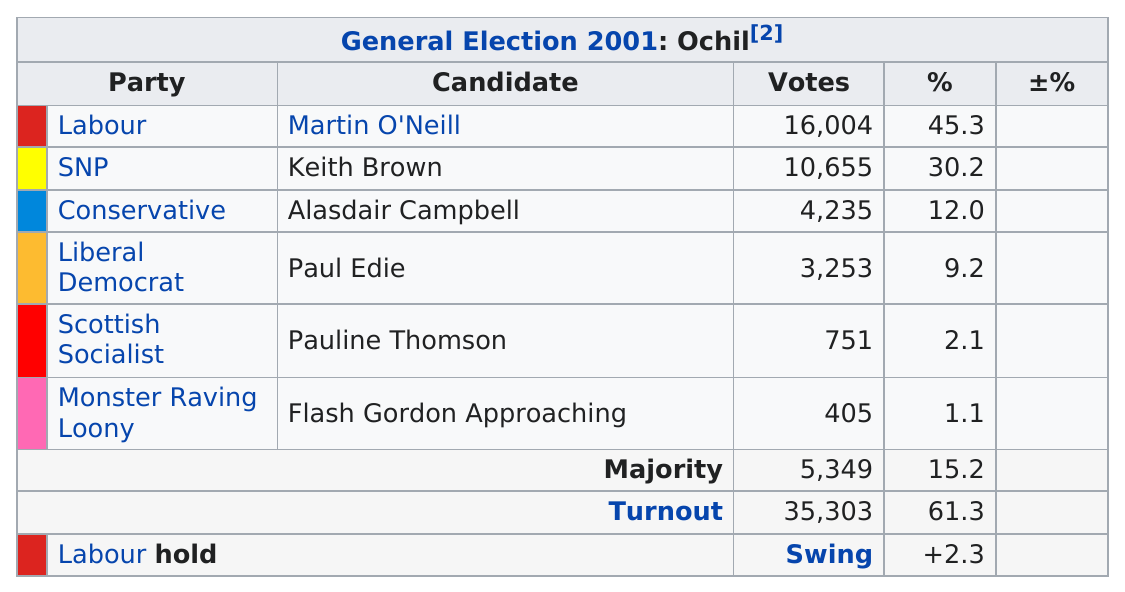Draw attention to some important aspects in this diagram. The SNP or the Conservative Party received a greater percentage of the vote in the 2001 General Election in Ochil. The following candidates received over one thousand votes: Martin O'Neill, Keith Brown, Alasdair Campbell, and Paul Edie. In the 2001 general election in Ochil, a candidate named Flash Gordon, who was affiliated with a satirical political party known as the Monster Raving Loony Party, approached the electorate. Despite their humorous and unconventional platform, the Monster Raving Loony Party came in last place in the election. 